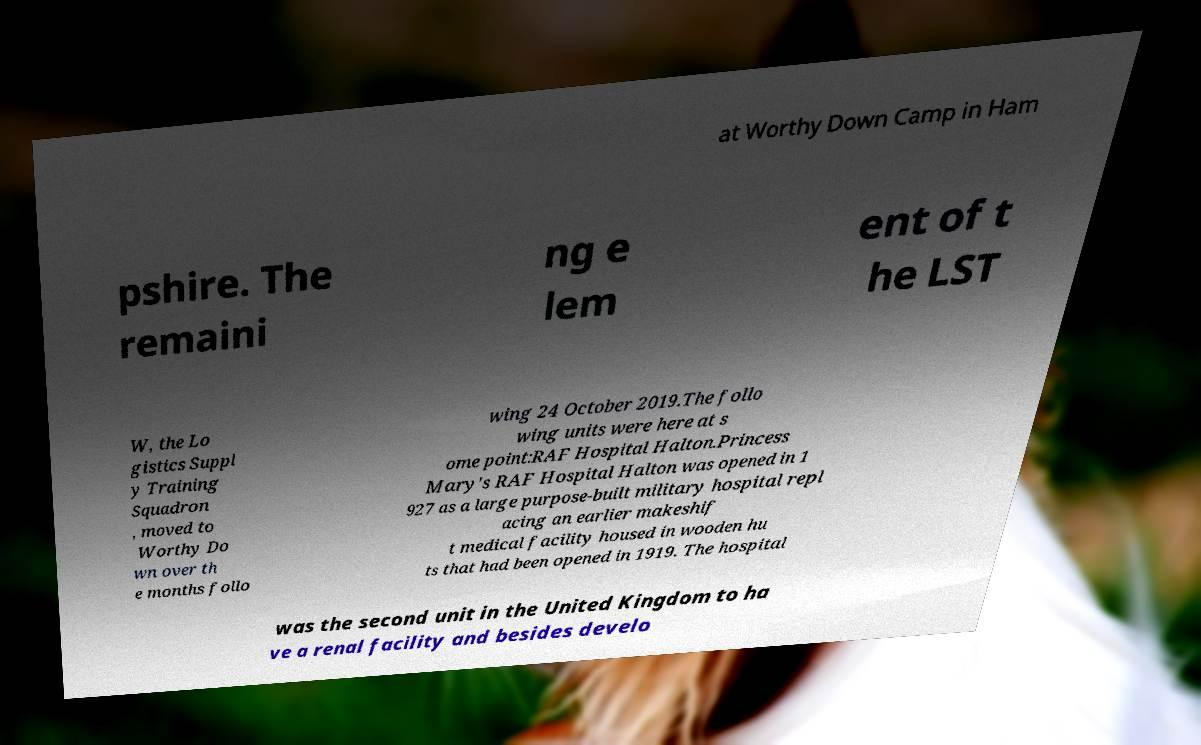Please read and relay the text visible in this image. What does it say? at Worthy Down Camp in Ham pshire. The remaini ng e lem ent of t he LST W, the Lo gistics Suppl y Training Squadron , moved to Worthy Do wn over th e months follo wing 24 October 2019.The follo wing units were here at s ome point:RAF Hospital Halton.Princess Mary's RAF Hospital Halton was opened in 1 927 as a large purpose-built military hospital repl acing an earlier makeshif t medical facility housed in wooden hu ts that had been opened in 1919. The hospital was the second unit in the United Kingdom to ha ve a renal facility and besides develo 